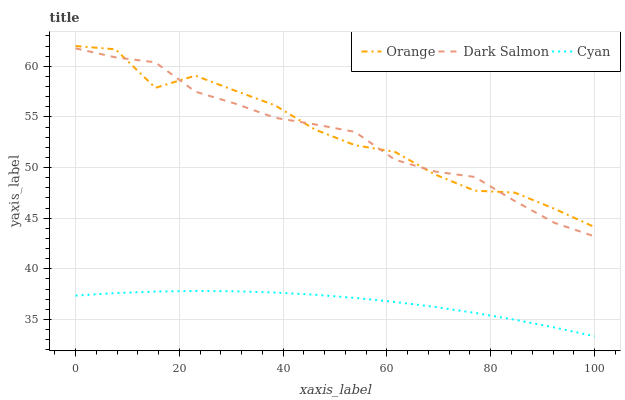Does Cyan have the minimum area under the curve?
Answer yes or no. Yes. Does Orange have the maximum area under the curve?
Answer yes or no. Yes. Does Dark Salmon have the minimum area under the curve?
Answer yes or no. No. Does Dark Salmon have the maximum area under the curve?
Answer yes or no. No. Is Cyan the smoothest?
Answer yes or no. Yes. Is Orange the roughest?
Answer yes or no. Yes. Is Dark Salmon the smoothest?
Answer yes or no. No. Is Dark Salmon the roughest?
Answer yes or no. No. Does Cyan have the lowest value?
Answer yes or no. Yes. Does Dark Salmon have the lowest value?
Answer yes or no. No. Does Orange have the highest value?
Answer yes or no. Yes. Does Dark Salmon have the highest value?
Answer yes or no. No. Is Cyan less than Orange?
Answer yes or no. Yes. Is Dark Salmon greater than Cyan?
Answer yes or no. Yes. Does Orange intersect Dark Salmon?
Answer yes or no. Yes. Is Orange less than Dark Salmon?
Answer yes or no. No. Is Orange greater than Dark Salmon?
Answer yes or no. No. Does Cyan intersect Orange?
Answer yes or no. No. 